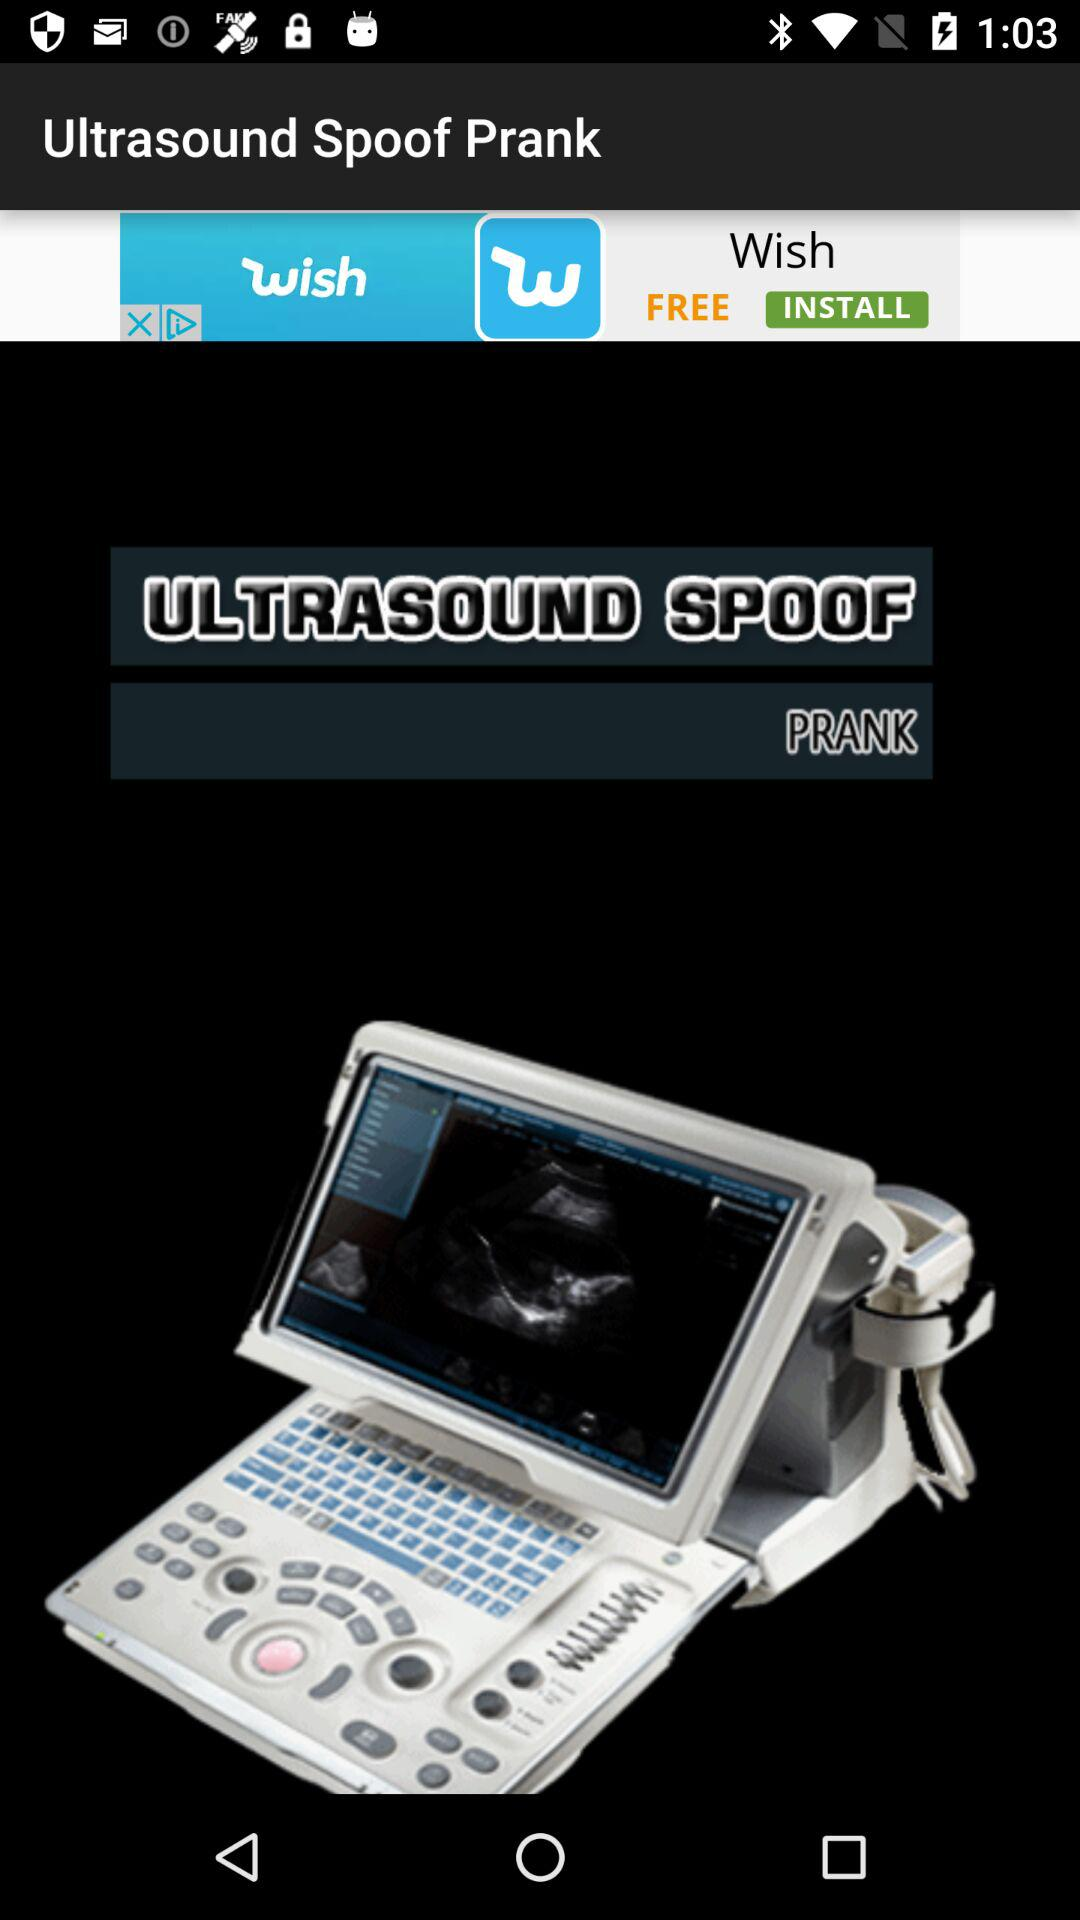What is the name of the application? The name of the application is "UltraSound Spoof". 